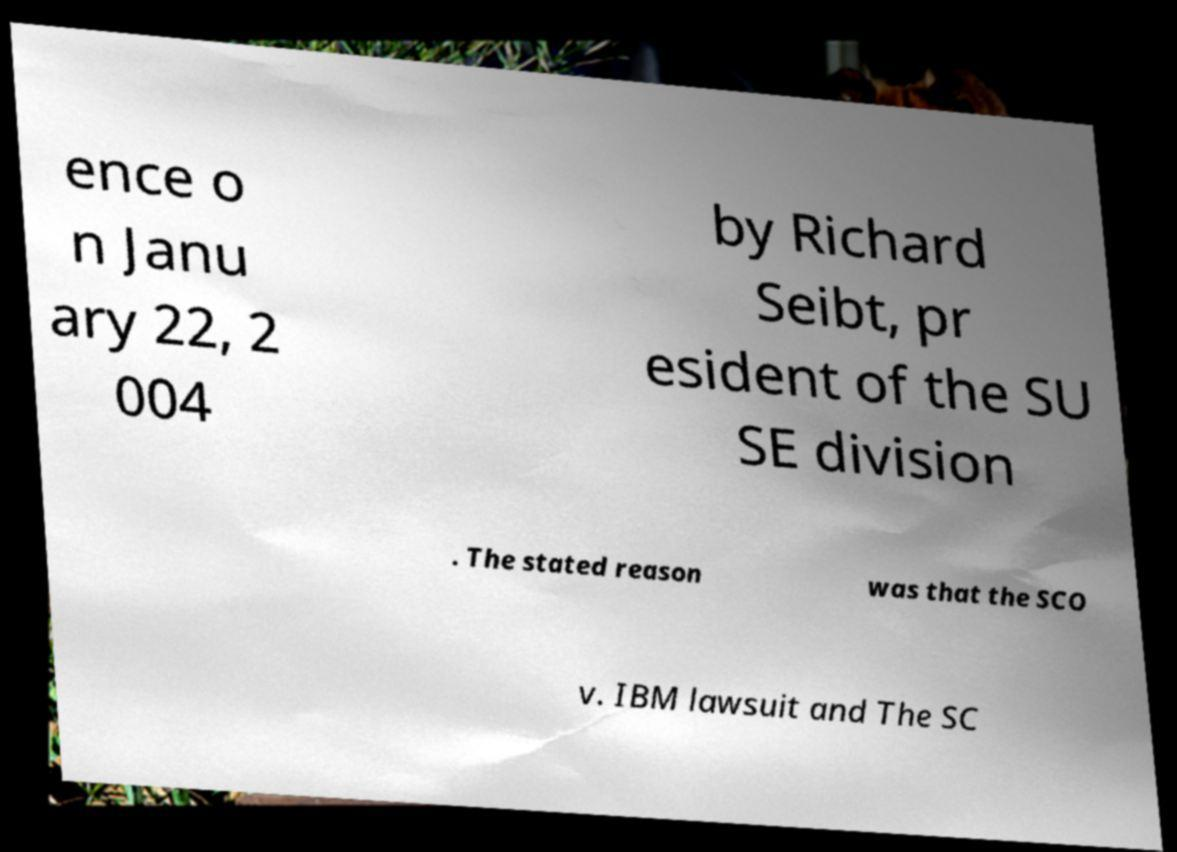Can you accurately transcribe the text from the provided image for me? ence o n Janu ary 22, 2 004 by Richard Seibt, pr esident of the SU SE division . The stated reason was that the SCO v. IBM lawsuit and The SC 